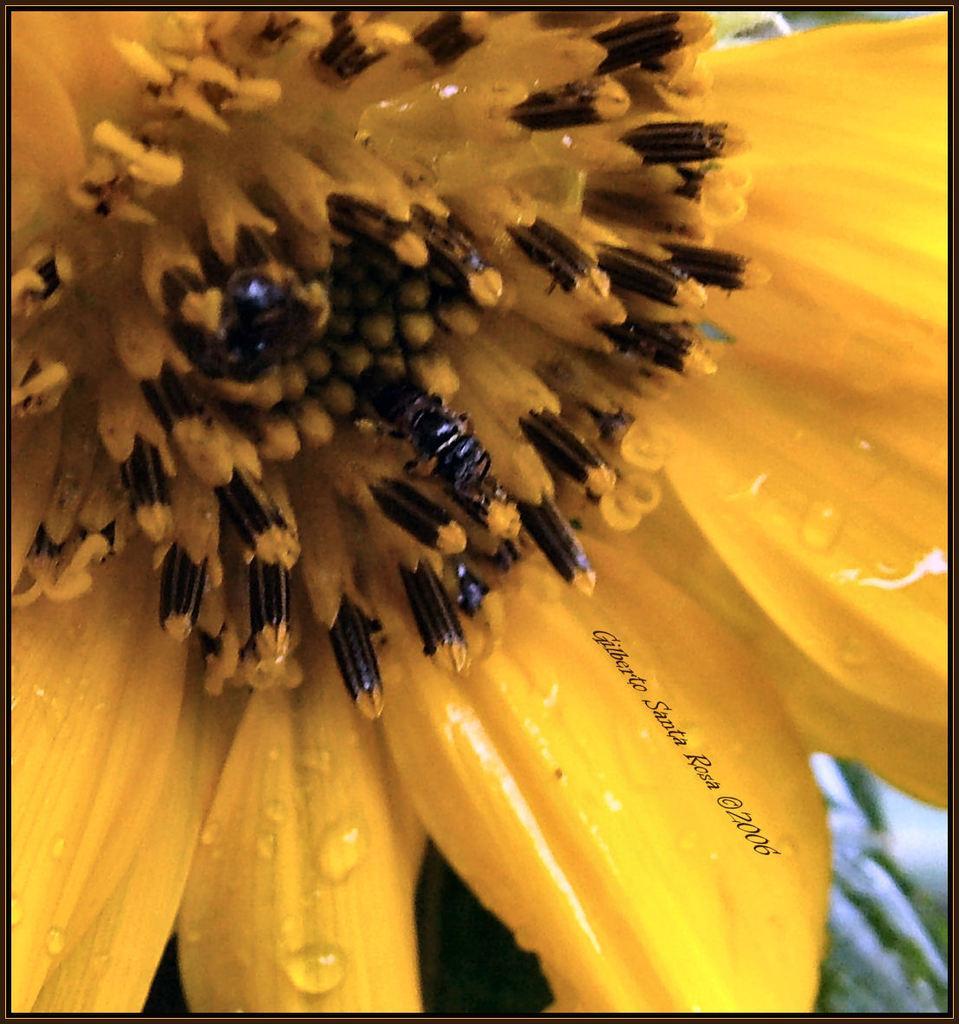In one or two sentences, can you explain what this image depicts? In the picture I can see a yellow color flower. I can also see a watermark on the image. 